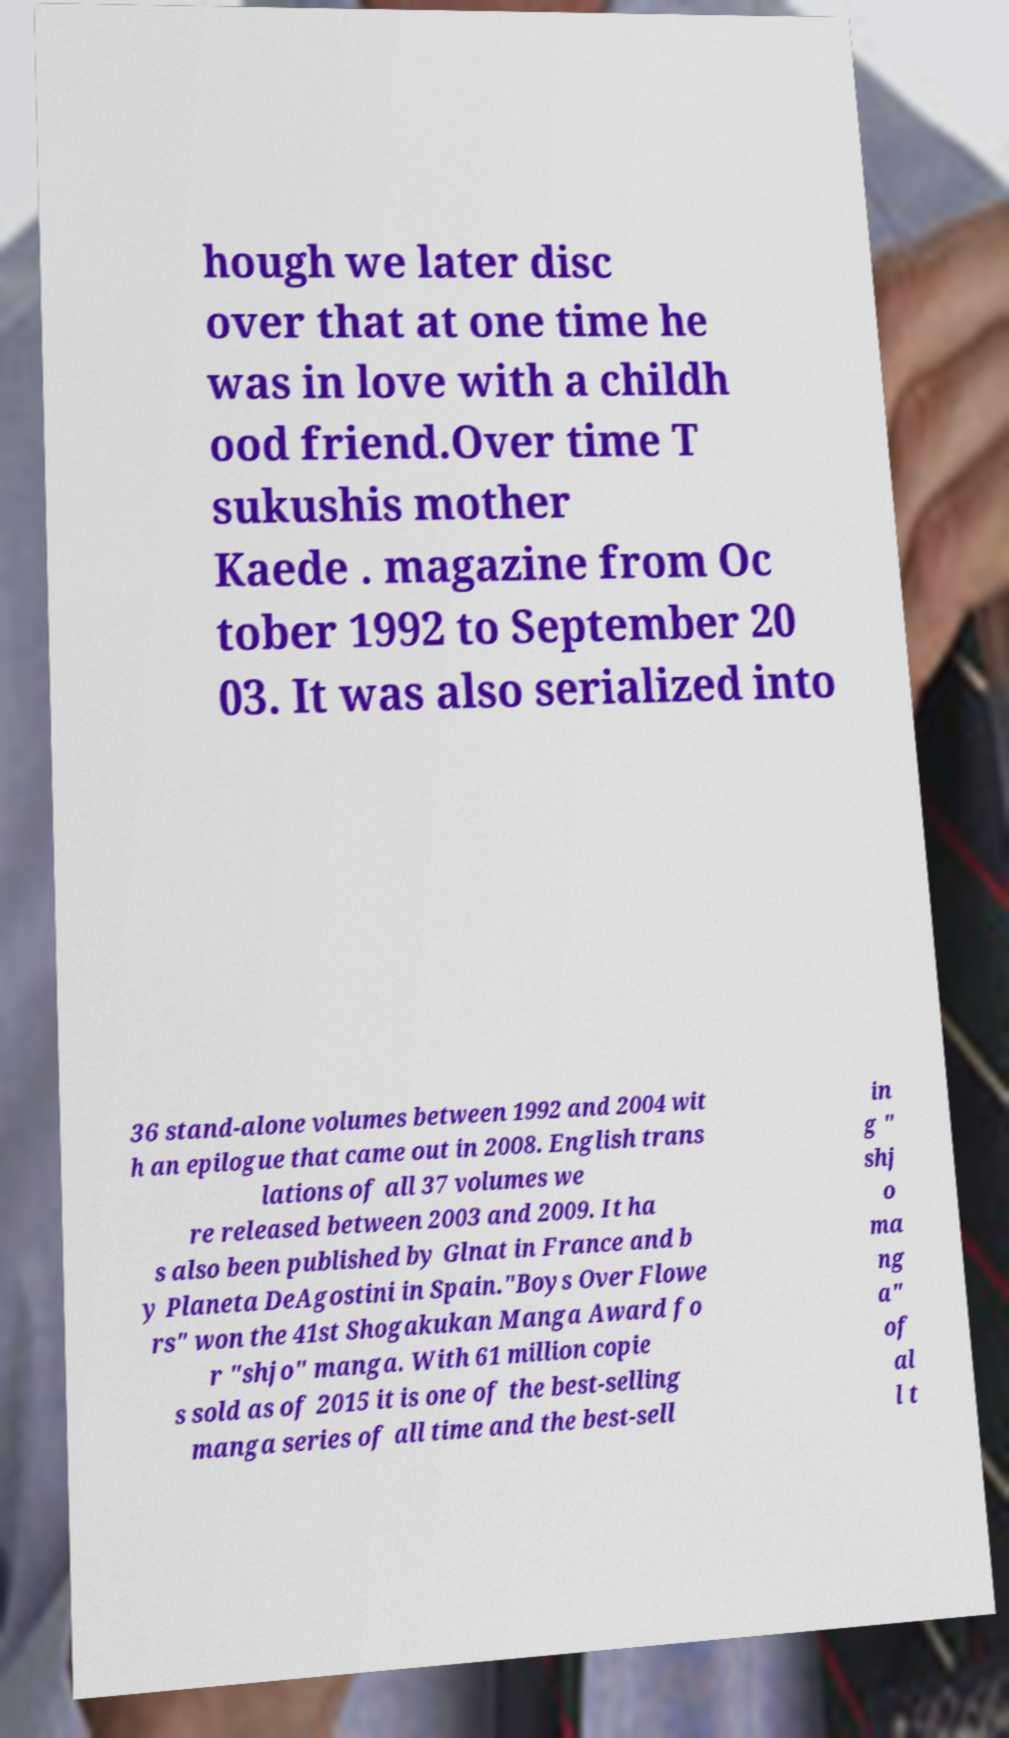What messages or text are displayed in this image? I need them in a readable, typed format. hough we later disc over that at one time he was in love with a childh ood friend.Over time T sukushis mother Kaede . magazine from Oc tober 1992 to September 20 03. It was also serialized into 36 stand-alone volumes between 1992 and 2004 wit h an epilogue that came out in 2008. English trans lations of all 37 volumes we re released between 2003 and 2009. It ha s also been published by Glnat in France and b y Planeta DeAgostini in Spain."Boys Over Flowe rs" won the 41st Shogakukan Manga Award fo r "shjo" manga. With 61 million copie s sold as of 2015 it is one of the best-selling manga series of all time and the best-sell in g " shj o ma ng a" of al l t 